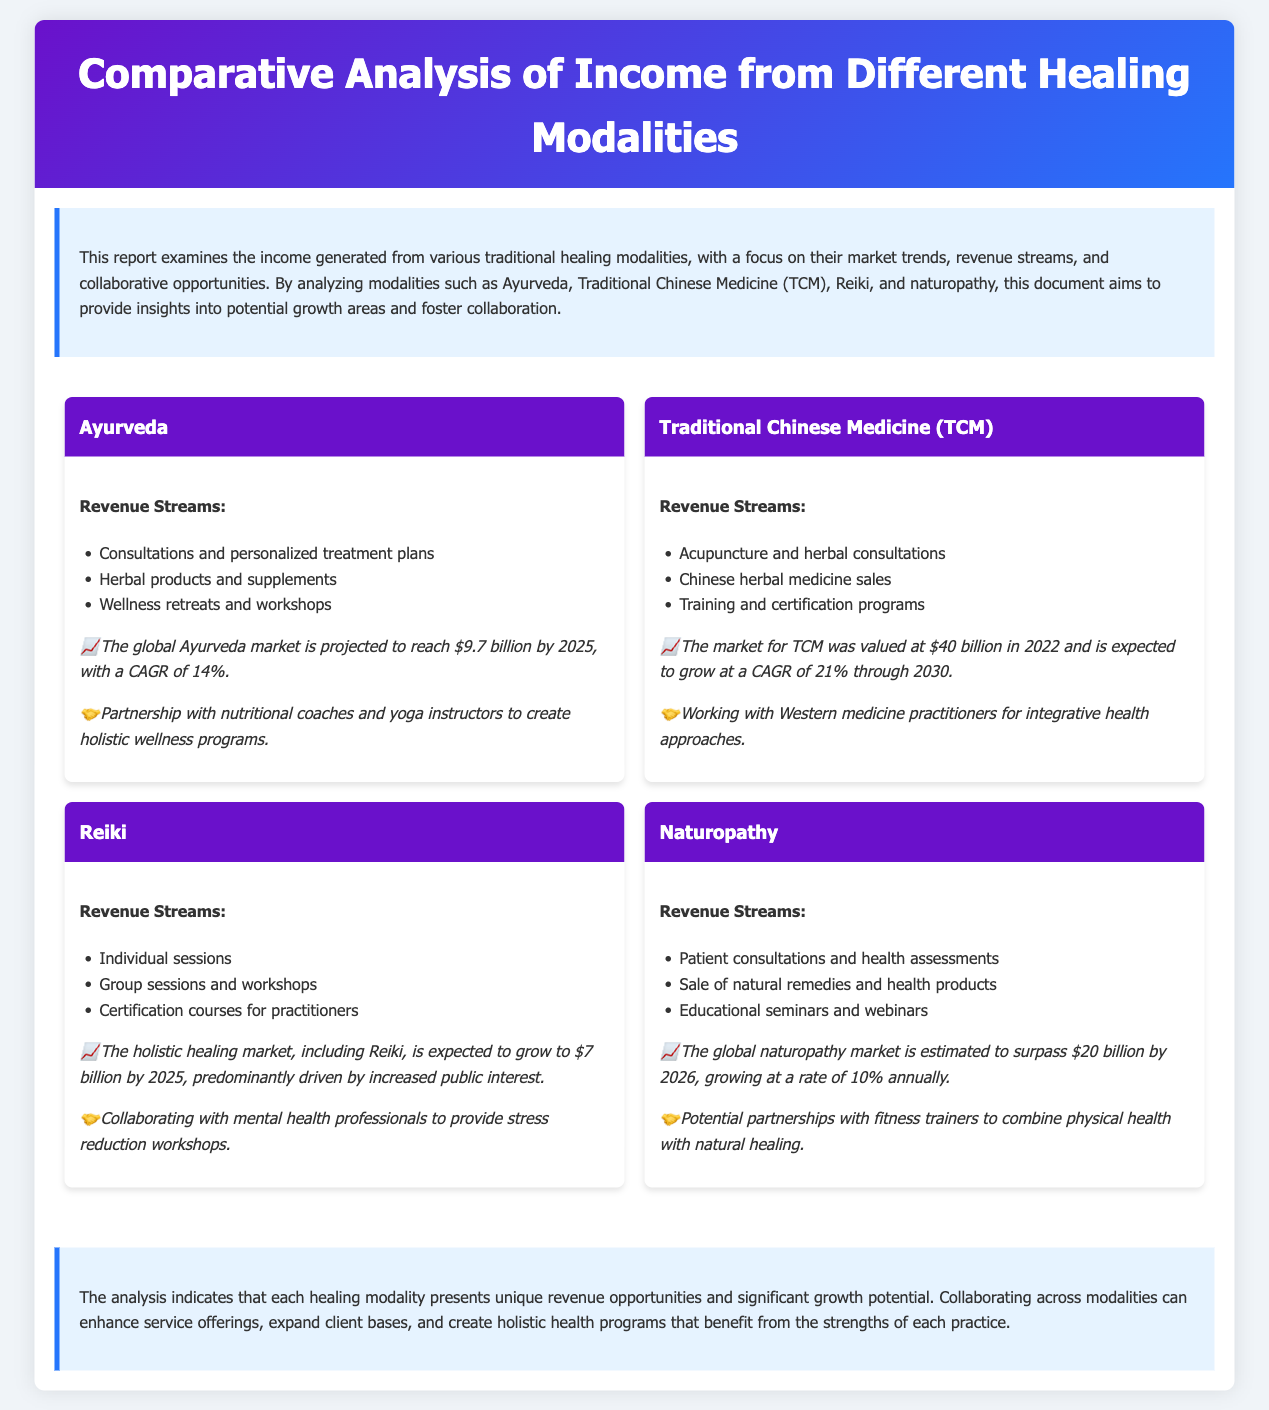What is the projected value of the global Ayurveda market by 2025? The document states that the global Ayurveda market is projected to reach $9.7 billion by 2025.
Answer: $9.7 billion What is the CAGR of Traditional Chinese Medicine (TCM)? The CAGR for TCM is expected to be 21% through 2030.
Answer: 21% What are the revenue streams for Reiki? Revenue streams include individual sessions, group sessions and workshops, and certification courses for practitioners.
Answer: Individual sessions, group sessions and workshops, certification courses Which healing modality has the highest market value in 2022? The market for TCM was valued at $40 billion in 2022.
Answer: $40 billion What potential collaboration is suggested for Ayurveda? The document suggests partnership with nutritional coaches and yoga instructors to create holistic wellness programs.
Answer: Nutritional coaches and yoga instructors Which market is expected to grow to $7 billion by 2025? The holistic healing market, including Reiki, is expected to grow to $7 billion by 2025.
Answer: Holistic healing market What is the expected growth rate for naturopathy annually? The expected growth rate for naturopathy is 10% annually.
Answer: 10% What type of professionals could Reiki practitioners collaborate with? Reiki practitioners could collaborate with mental health professionals to provide stress reduction workshops.
Answer: Mental health professionals 